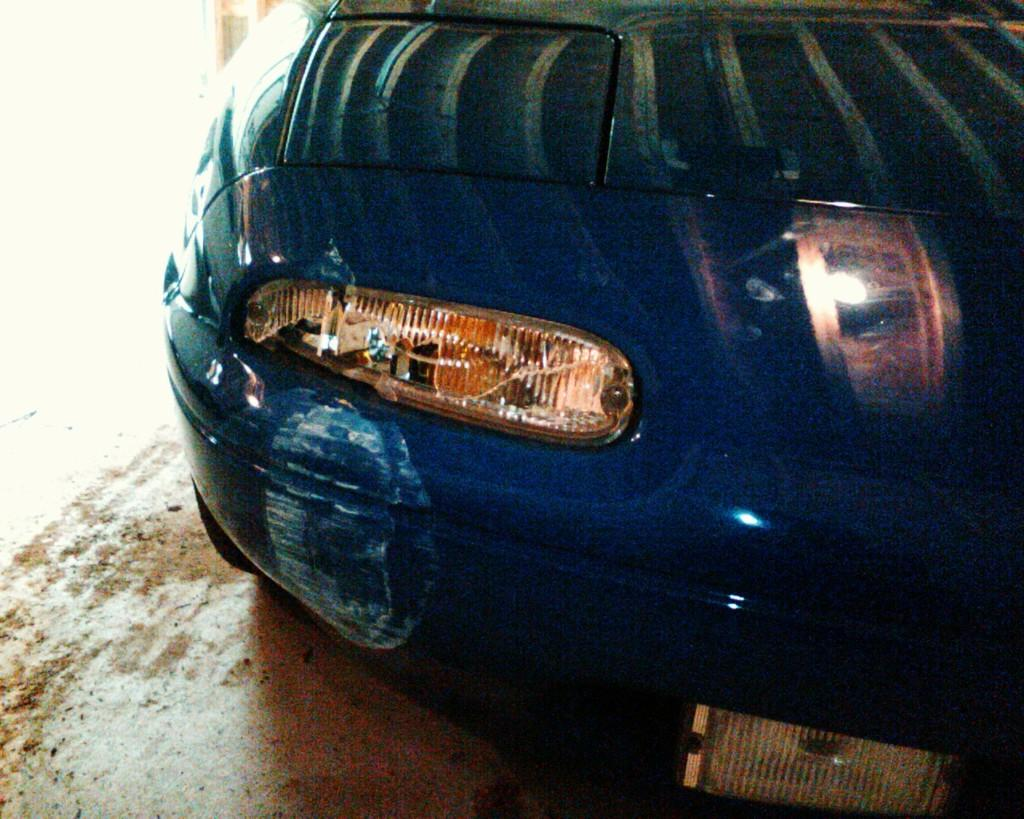What is the main subject of the image? The main subject of the image is a car. Can you describe the position of the car in the image? The car is on the ground in the image. What type of structure is being built in the image? There is no structure being built in the image; it only features a car on the ground. What type of light source is illuminating the car in the image? There is no specific light source mentioned or visible in the image; it only shows a car on the ground. 